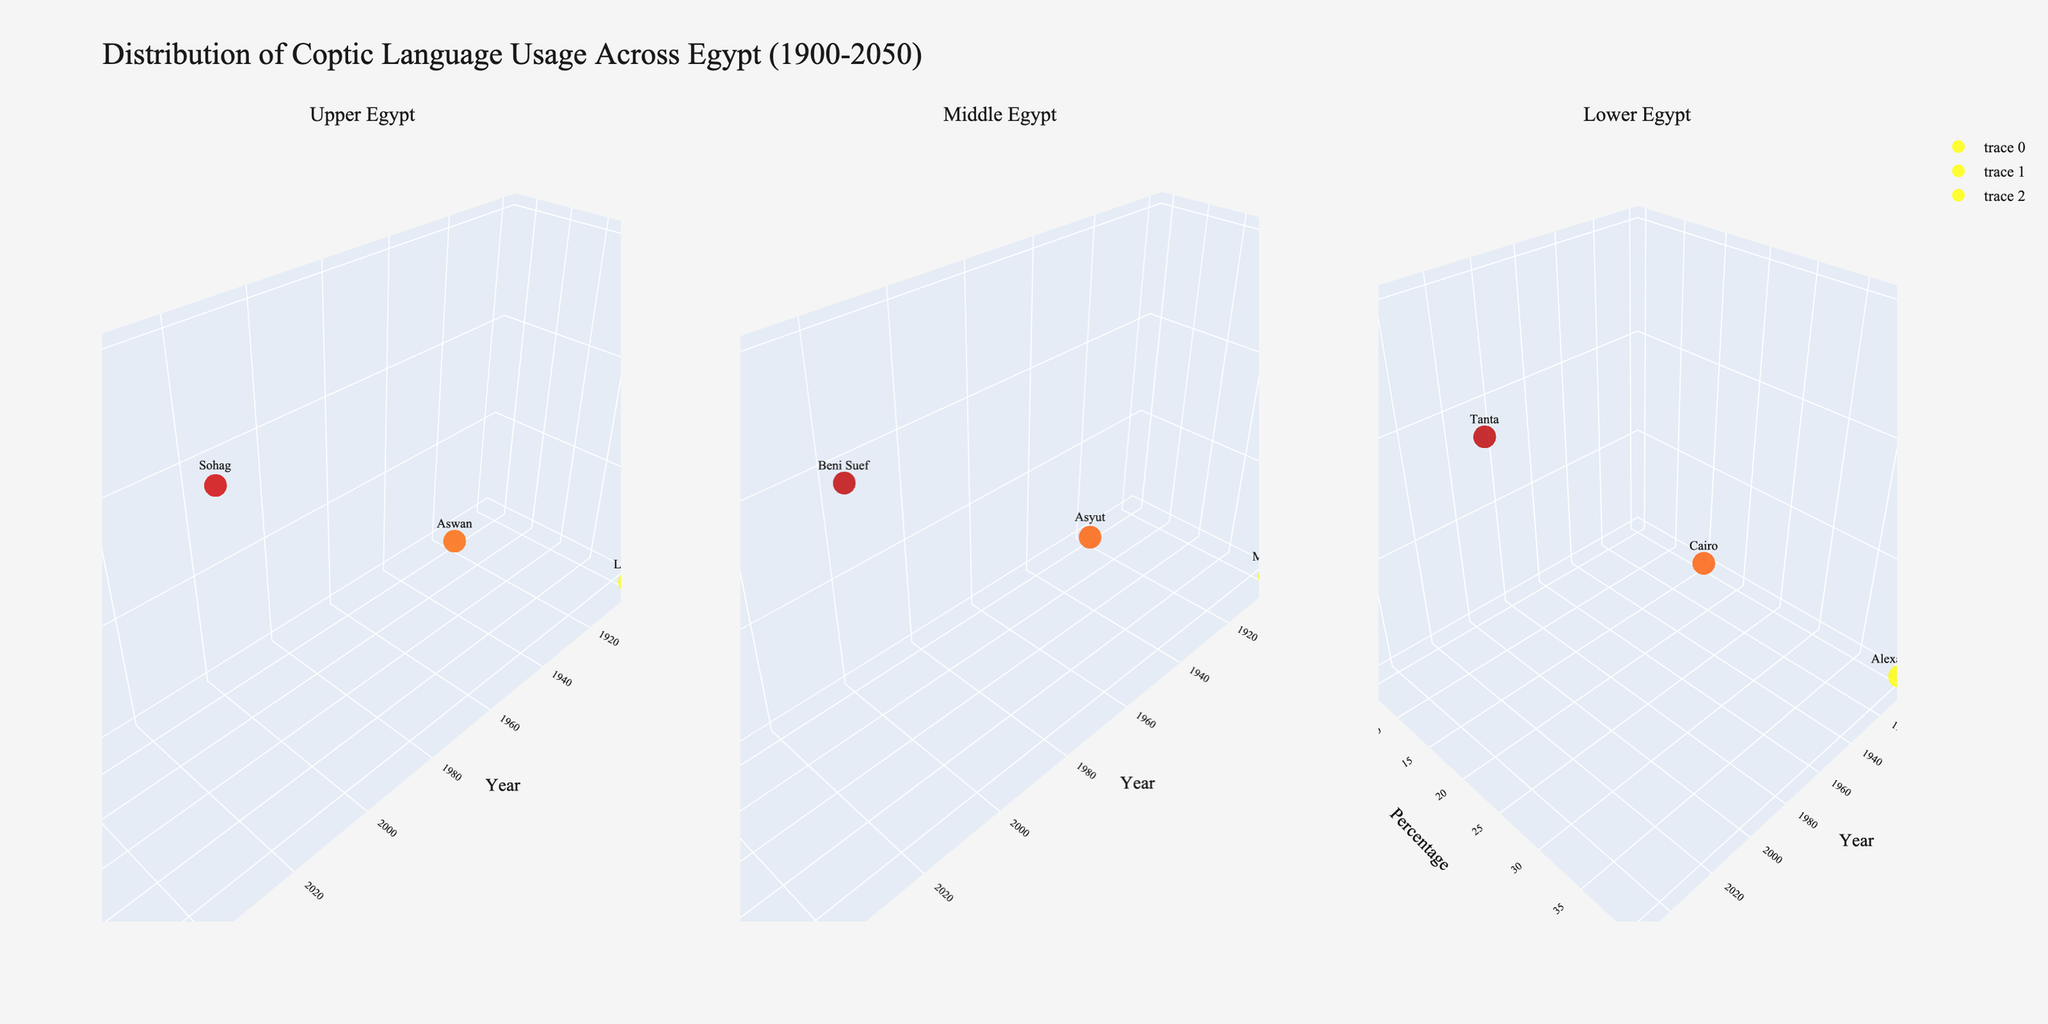What is the title of the figure? The title of the figure is displayed at the top center and reads "Distribution of Coptic Language Usage Across Egypt (1900-2050)".
Answer: Distribution of Coptic Language Usage Across Egypt (1900-2050) Which regions are represented in the subplots? The subplot titles indicate the regions as "Upper Egypt", "Middle Egypt", and "Lower Egypt".
Answer: Upper Egypt, Middle Egypt, Lower Egypt In which region and year is the highest percentage of Coptic language usage recorded? By looking at the 3D scatter plots, the highest percentage (65%) is recorded in Upper Egypt in the year 1900.
Answer: Upper Egypt in 1900 Which city shows the lowest percentage of Coptic language usage in 2050? In the 2050 scatter points, Port Said in Lower Egypt shows the lowest percentage (5%).
Answer: Port Said Compare the trend of Coptic language usage in Upper Egypt between 1900 and 2050. In Upper Egypt, the percentage decreases from 65% in 1900 to 45% in 1950, 25% in 2000, and 15% in 2050, indicating a clear downward trend over time.
Answer: Decreasing trend Which region shows the most significant drop in Coptic language usage from 1900 to 1950? By comparing the percentages, Upper Egypt drops from 65% to 45%, Middle Egypt from 55% to 35%, and Lower Egypt from 40% to 25%. The most significant drop is in Upper Egypt (20%).
Answer: Upper Egypt What is the average percentage of Coptic language usage in Middle Egypt over the years shown? Middle Egypt has percentages: 55 (1900), 35 (1950), 15 (2000), and 8 (2050). The average is (55+35+15+8)/4 = 28.25.
Answer: 28.25 Is there any city that appears in two different regions in the data? By observing the cities in each subplot, no city is found to be repeated among different regions.
Answer: No 